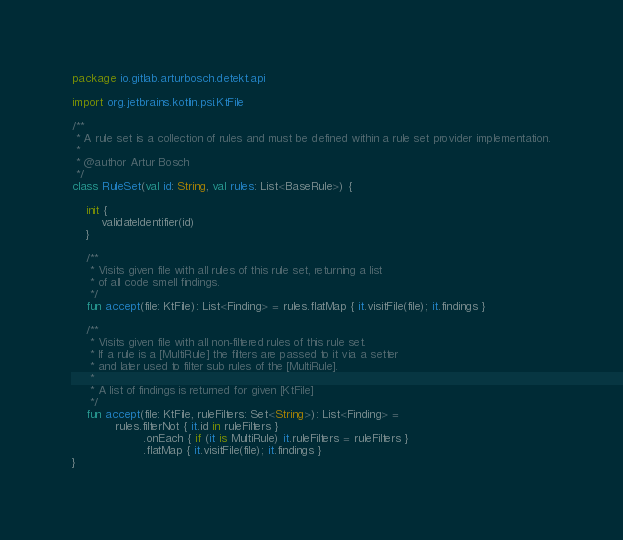Convert code to text. <code><loc_0><loc_0><loc_500><loc_500><_Kotlin_>package io.gitlab.arturbosch.detekt.api

import org.jetbrains.kotlin.psi.KtFile

/**
 * A rule set is a collection of rules and must be defined within a rule set provider implementation.
 *
 * @author Artur Bosch
 */
class RuleSet(val id: String, val rules: List<BaseRule>) {

	init {
		validateIdentifier(id)
	}

	/**
	 * Visits given file with all rules of this rule set, returning a list
	 * of all code smell findings.
	 */
	fun accept(file: KtFile): List<Finding> = rules.flatMap { it.visitFile(file); it.findings }

	/**
	 * Visits given file with all non-filtered rules of this rule set.
	 * If a rule is a [MultiRule] the filters are passed to it via a setter
	 * and later used to filter sub rules of the [MultiRule].
	 *
	 * A list of findings is returned for given [KtFile]
	 */
	fun accept(file: KtFile, ruleFilters: Set<String>): List<Finding> =
			rules.filterNot { it.id in ruleFilters }
					.onEach { if (it is MultiRule) it.ruleFilters = ruleFilters }
					.flatMap { it.visitFile(file); it.findings }
}
</code> 